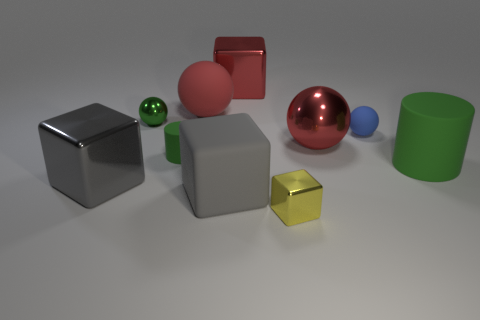Are there any big green cylinders that have the same material as the tiny blue thing?
Offer a very short reply. Yes. What material is the tiny thing that is behind the small matte object on the right side of the red rubber sphere?
Offer a terse response. Metal. There is a large red object that is right of the big rubber ball and behind the tiny metallic sphere; what is its material?
Offer a very short reply. Metal. Are there an equal number of red matte things to the right of the rubber cube and small red rubber spheres?
Your answer should be very brief. Yes. What number of big green rubber objects have the same shape as the green shiny thing?
Provide a short and direct response. 0. How big is the matte ball that is right of the large ball that is right of the big red shiny thing that is behind the blue matte thing?
Your response must be concise. Small. Is the large gray cube on the right side of the large red matte object made of the same material as the big green cylinder?
Ensure brevity in your answer.  Yes. Are there the same number of tiny green metallic objects right of the blue rubber sphere and large green rubber cylinders that are on the left side of the big matte cube?
Your response must be concise. Yes. There is another tiny thing that is the same shape as the gray matte object; what is its material?
Provide a succinct answer. Metal. There is a big block that is behind the green rubber object on the left side of the red metallic ball; are there any tiny metal balls to the left of it?
Keep it short and to the point. Yes. 